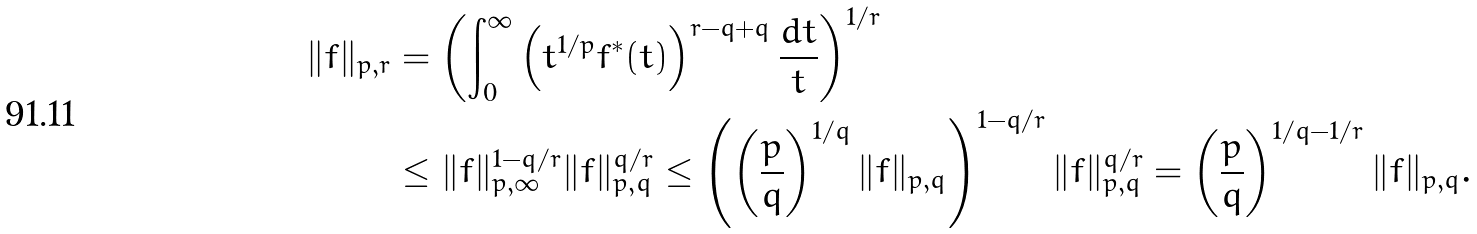Convert formula to latex. <formula><loc_0><loc_0><loc_500><loc_500>\| f \| _ { p , r } & = \left ( \int _ { 0 } ^ { \infty } \left ( t ^ { 1 / p } f ^ { * } ( t ) \right ) ^ { r - q + q } \frac { d t } { t } \right ) ^ { 1 / r } \\ & \leq \| f \| _ { p , \infty } ^ { 1 - q / r } \| f \| _ { p , q } ^ { q / r } \leq \left ( \left ( \frac { p } { q } \right ) ^ { 1 / q } \| f \| _ { p , q } \right ) ^ { 1 - q / r } \| f \| _ { p , q } ^ { q / r } = \left ( \frac { p } { q } \right ) ^ { 1 / q - 1 / r } \| f \| _ { p , q } .</formula> 